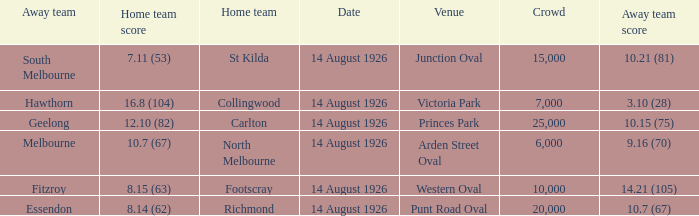What was the crowd size at Victoria Park? 7000.0. 